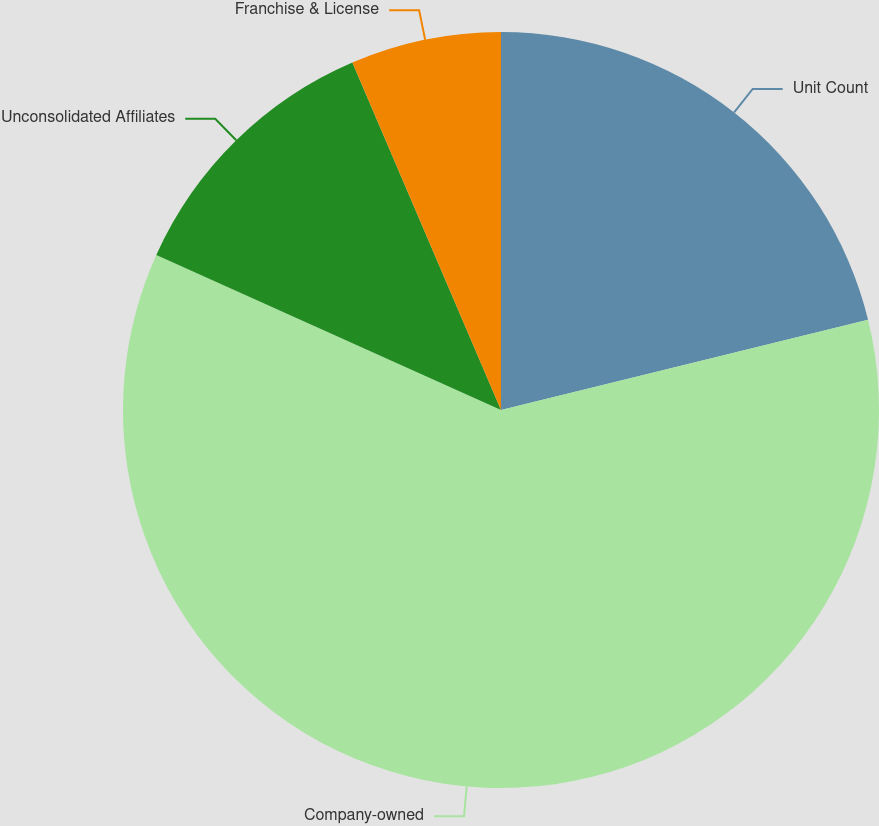<chart> <loc_0><loc_0><loc_500><loc_500><pie_chart><fcel>Unit Count<fcel>Company-owned<fcel>Unconsolidated Affiliates<fcel>Franchise & License<nl><fcel>21.16%<fcel>60.57%<fcel>11.84%<fcel>6.43%<nl></chart> 